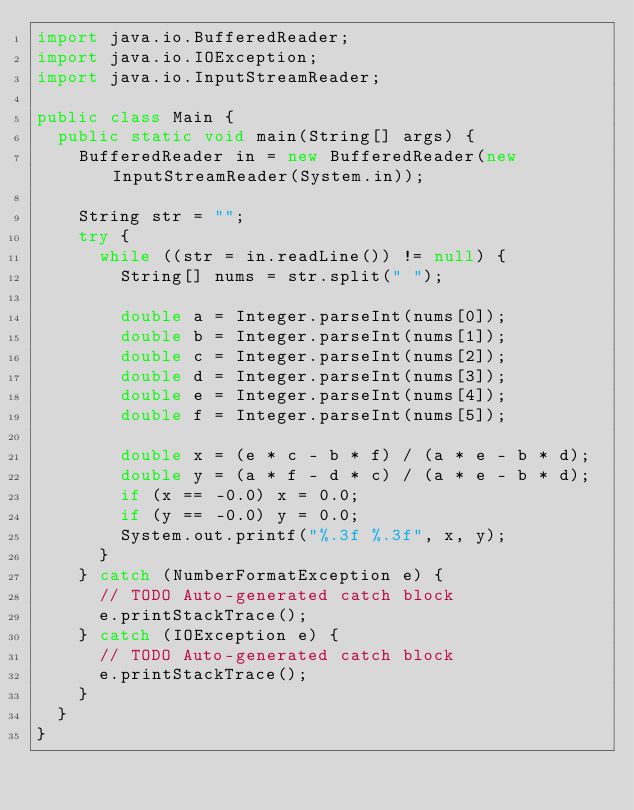<code> <loc_0><loc_0><loc_500><loc_500><_Java_>import java.io.BufferedReader;
import java.io.IOException;
import java.io.InputStreamReader;

public class Main {
	public static void main(String[] args) {
		BufferedReader in = new BufferedReader(new InputStreamReader(System.in));
	    
		String str = "";
		try {
			while ((str = in.readLine()) != null) {
				String[] nums = str.split(" ");

				double a = Integer.parseInt(nums[0]);
				double b = Integer.parseInt(nums[1]);
				double c = Integer.parseInt(nums[2]);
				double d = Integer.parseInt(nums[3]);
				double e = Integer.parseInt(nums[4]);
				double f = Integer.parseInt(nums[5]);
				
				double x = (e * c - b * f) / (a * e - b * d);
				double y = (a * f - d * c) / (a * e - b * d);
				if (x == -0.0) x = 0.0;
				if (y == -0.0) y = 0.0;
				System.out.printf("%.3f %.3f", x, y);
			}
		} catch (NumberFormatException e) {
			// TODO Auto-generated catch block
			e.printStackTrace();
		} catch (IOException e) {
			// TODO Auto-generated catch block
			e.printStackTrace();
		}
	}
}</code> 